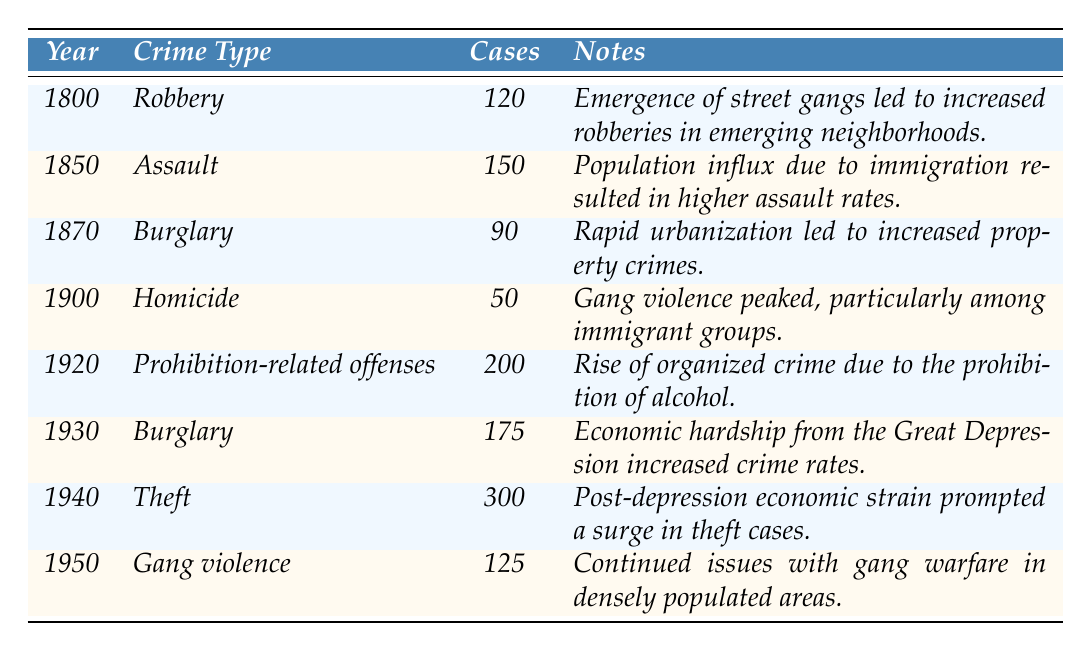What year had the highest number of reported theft cases? According to the table, the year with the highest reported theft cases was 1940, with 300 reported cases.
Answer: 1940 What crime type was reported in 1920? The table indicates that the crime type reported in 1920 was "Prohibition-related offenses" with 200 cases.
Answer: Prohibition-related offenses How many reported cases of burglary were there in 1930? The table shows that in 1930, there were 175 reported cases of burglary.
Answer: 175 What was the total reported cases for robbery in 1800 and homicide in 1900? The total reported cases for robbery in 1800 is 120, and for homicide in 1900 is 50. Summing these gives 120 + 50 = 170.
Answer: 170 Did the number of reported cases of gang violence increase from 1900 to 1950? The number of reported cases of gang violence in 1900 was not specified; however, in 1950, there were 125 reported cases. The data for 1900 does not include gang violence specifically but mentions gang violence peak, which indicates it might have been significant. Therefore, it's inconclusive to determine an increase without specific values for both years.
Answer: No What was the average number of reported cases across all years? To find the average, add the reported cases for each year: 120 + 150 + 90 + 50 + 200 + 175 + 300 + 125 = 1210. There are 8 data points, so the average is 1210 / 8 = 151.25.
Answer: 151.25 Which crime type had the least reported cases in the table? The crime type with the least reported cases in the table was homicide in 1900 with 50 cases.
Answer: Homicide Was the increase in burglary cases from 1870 to 1930 significant? In 1870, burglary cases were 90, and in 1930, they rose to 175. The difference is 175 - 90 = 85, which is a significant increase.
Answer: Yes What can we infer about crime rates during the Prohibition era in 1920? In 1920, the number of reported cases for Prohibition-related offenses was the highest at 200, suggesting a rise in organized crime associated with alcohol prohibition.
Answer: Rise in organized crime 